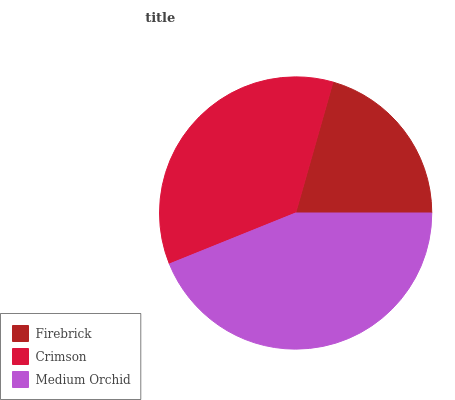Is Firebrick the minimum?
Answer yes or no. Yes. Is Medium Orchid the maximum?
Answer yes or no. Yes. Is Crimson the minimum?
Answer yes or no. No. Is Crimson the maximum?
Answer yes or no. No. Is Crimson greater than Firebrick?
Answer yes or no. Yes. Is Firebrick less than Crimson?
Answer yes or no. Yes. Is Firebrick greater than Crimson?
Answer yes or no. No. Is Crimson less than Firebrick?
Answer yes or no. No. Is Crimson the high median?
Answer yes or no. Yes. Is Crimson the low median?
Answer yes or no. Yes. Is Medium Orchid the high median?
Answer yes or no. No. Is Medium Orchid the low median?
Answer yes or no. No. 